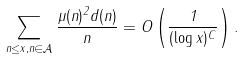<formula> <loc_0><loc_0><loc_500><loc_500>\sum _ { n \leq x , n \in \mathcal { A } } \frac { \mu ( n ) ^ { 2 } d ( n ) } { n } = O \left ( \frac { 1 } { ( \log x ) ^ { C } } \right ) .</formula> 